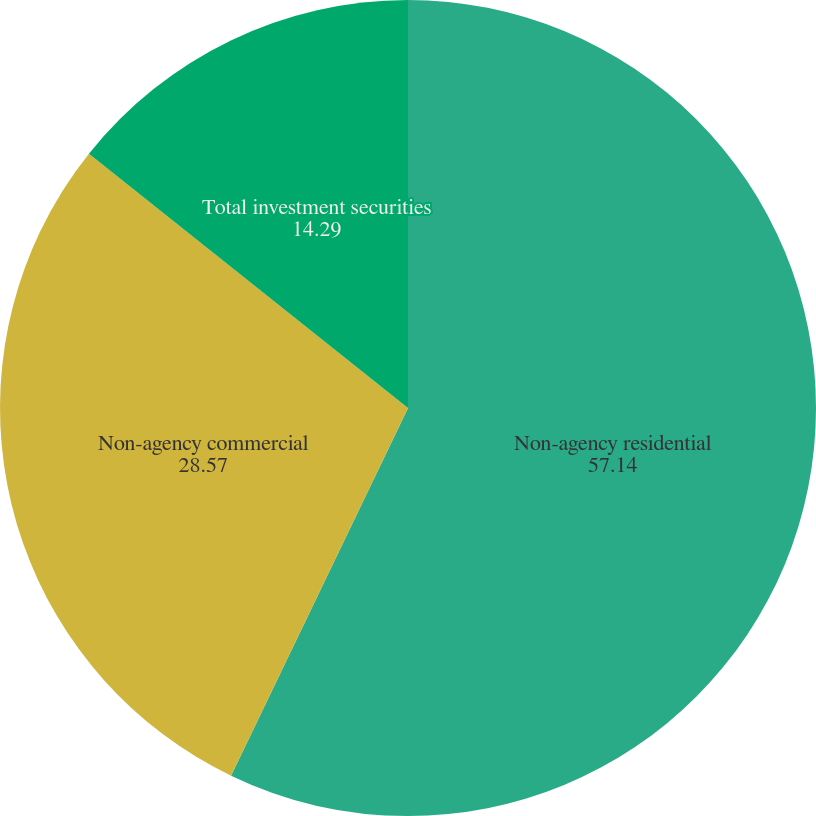Convert chart. <chart><loc_0><loc_0><loc_500><loc_500><pie_chart><fcel>Non-agency residential<fcel>Non-agency commercial<fcel>Total investment securities<nl><fcel>57.14%<fcel>28.57%<fcel>14.29%<nl></chart> 